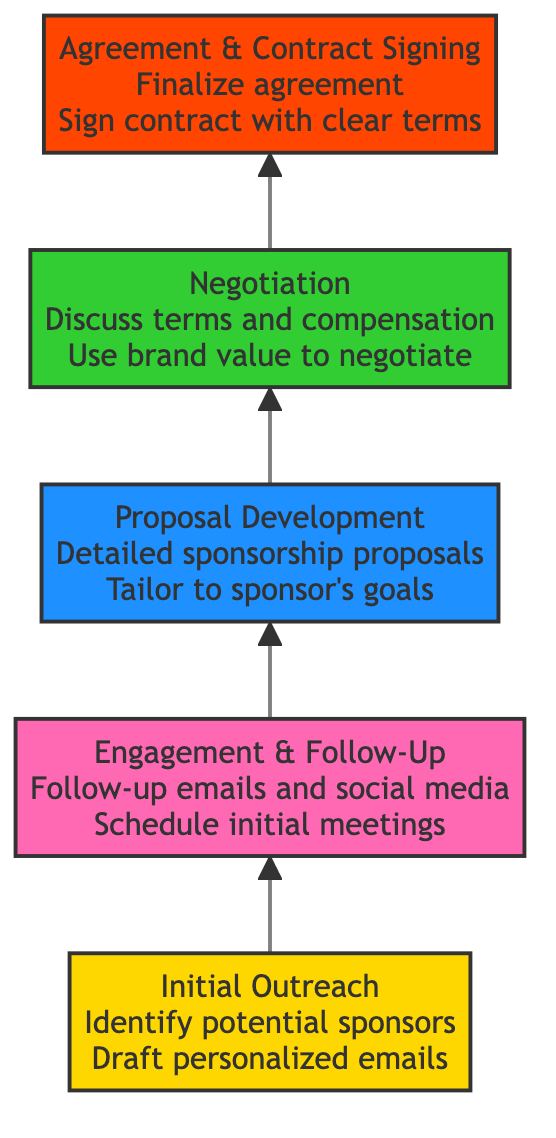What is the title of the top node in the diagram? The top node in the diagram is "Agreement & Contract Signing," as it is the final stage in the flow chart that represents the endpoint of the sponsorship acquisition process.
Answer: Agreement & Contract Signing How many levels are depicted in the diagram? The diagram consists of five distinct levels, each representing a unique stage in the sponsorship acquisition process.
Answer: Five What is the first step after "Initial Outreach"? The first step after "Initial Outreach" is "Engagement & Follow-Up," which involves maintaining interest from potential sponsors through additional communication and meetings.
Answer: Engagement & Follow-Up Which step directly precedes "Agreement & Contract Signing"? The step that directly precedes "Agreement & Contract Signing" is "Negotiation," where the terms and deliverables are discussed before finalizing the contract.
Answer: Negotiation What color represents "Proposal Development"? "Proposal Development" is represented in light blue, which distinguishes it from the other steps in the diagram.
Answer: Light blue What action is suggested in "Engagement & Follow-Up"? "Engagement & Follow-Up" suggests taking actions such as sending follow-up emails and social media shoutouts to maintain sponsor interest.
Answer: Follow-up emails and social media Which node discusses the tailoring of proposals to match sponsor goals? "Proposal Development" is the node that addresses the importance of tailoring sponsorship proposals to align with the specific goals of potential sponsors.
Answer: Proposal Development What is the key focus during the "Negotiation" stage? The key focus during the "Negotiation" stage is to discuss terms, deliverables, and compensation, utilizing past partnership insights to achieve favorable outcomes.
Answer: Discuss terms How does the flow start in this diagram? The flow starts with the "Initial Outreach" step, which serves as the foundation for initiating potential sponsorships with identified brands.
Answer: Initial Outreach What does the final step ensure regarding the contract? The final step ensures that all terms of the contract are clearly defined and that both parties have aligned expectations for deliverables and timelines.
Answer: Clearly defined terms 